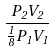Convert formula to latex. <formula><loc_0><loc_0><loc_500><loc_500>\frac { P _ { 2 } V _ { 2 } } { \frac { 1 } { 8 } P _ { 1 } V _ { 1 } }</formula> 